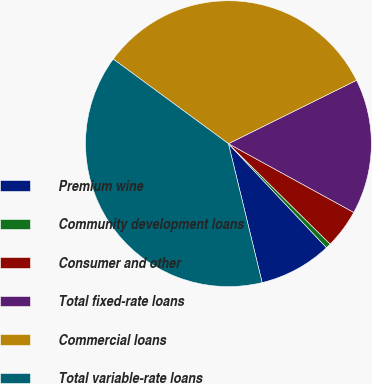<chart> <loc_0><loc_0><loc_500><loc_500><pie_chart><fcel>Premium wine<fcel>Community development loans<fcel>Consumer and other<fcel>Total fixed-rate loans<fcel>Commercial loans<fcel>Total variable-rate loans<nl><fcel>8.24%<fcel>0.58%<fcel>4.41%<fcel>15.3%<fcel>32.6%<fcel>38.87%<nl></chart> 